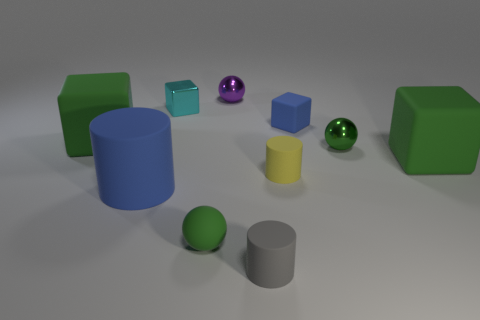Subtract all green blocks. How many were subtracted if there are1green blocks left? 1 Subtract all blue blocks. How many blocks are left? 3 Subtract all tiny blue rubber cubes. How many cubes are left? 3 Subtract 2 cubes. How many cubes are left? 2 Subtract all gray blocks. Subtract all gray spheres. How many blocks are left? 4 Subtract all spheres. How many objects are left? 7 Add 1 small metallic objects. How many small metallic objects exist? 4 Subtract 1 yellow cylinders. How many objects are left? 9 Subtract all small gray metallic objects. Subtract all metal spheres. How many objects are left? 8 Add 9 tiny gray rubber objects. How many tiny gray rubber objects are left? 10 